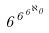Convert formula to latex. <formula><loc_0><loc_0><loc_500><loc_500>6 ^ { 6 ^ { 6 ^ { \aleph _ { 0 } } } }</formula> 